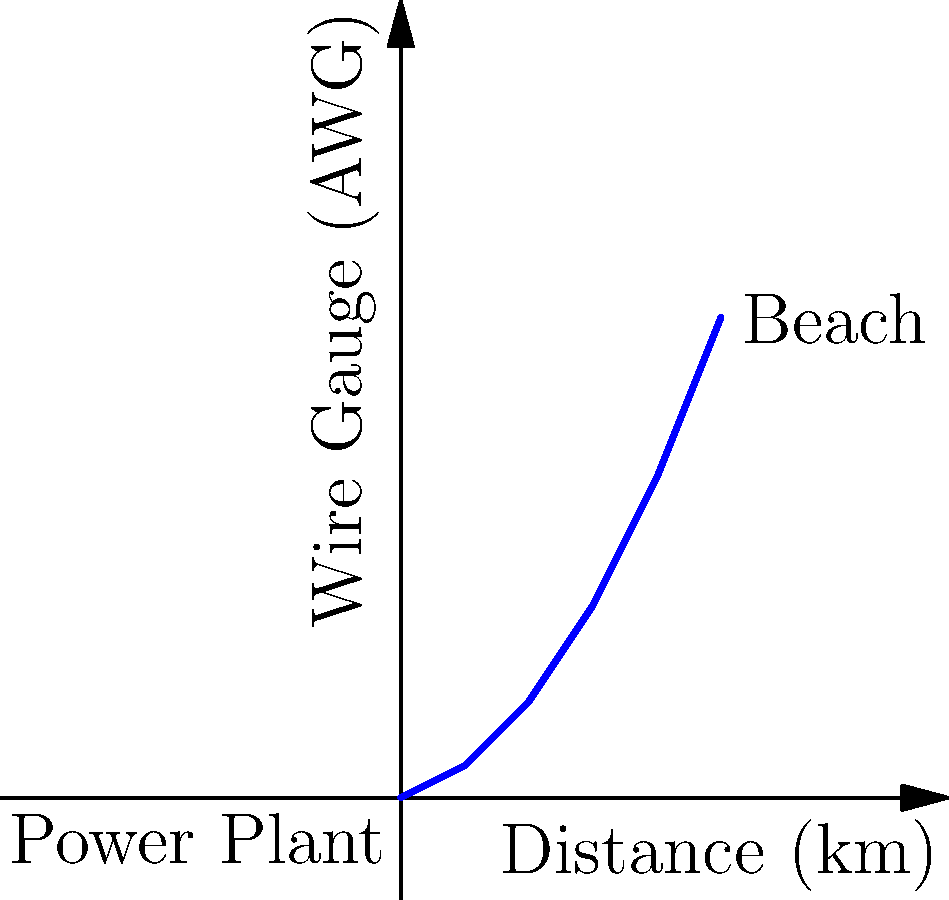A new power line is being installed to connect a coastal beach area in Newhaven to the main power grid. The distance from the power plant to the beach is 5 km. Given that the required current capacity is 100 A and the maximum allowable voltage drop is 2%, what is the minimum American Wire Gauge (AWG) needed for this power line? Assume the power line operates at 11 kV and the resistivity of copper is $1.68 \times 10^{-8}$ Ω⋅m. To determine the minimum wire gauge, we'll follow these steps:

1) First, calculate the maximum allowable resistance of the wire:
   Voltage drop = Current × Resistance
   $0.02 \times 11000 \text{ V} = 100 \text{ A} \times R$
   $R = \frac{220 \text{ V}}{100 \text{ A}} = 2.2 \text{ Ω}$

2) The resistance of a wire is given by:
   $R = \rho \frac{L}{A}$
   where $\rho$ is resistivity, $L$ is length, and $A$ is cross-sectional area.

3) Rearrange to solve for area:
   $A = \rho \frac{L}{R}$

4) Substitute known values:
   $A = (1.68 \times 10^{-8} \text{ Ω⋅m}) \frac{5000 \text{ m}}{2.2 \text{ Ω}} = 3.82 \times 10^{-5} \text{ m}^2$

5) Convert area to circular mils (CM):
   $1 \text{ CM} = 5.067 \times 10^{-10} \text{ m}^2$
   $A = 3.82 \times 10^{-5} \text{ m}^2 \div (5.067 \times 10^{-10} \text{ m}^2/\text{CM}) = 75,390 \text{ CM}$

6) Use AWG table to find the closest larger wire size:
   The closest larger size is AWG 1, which has a circular mil area of 83,690 CM.

Therefore, the minimum wire gauge needed is AWG 1.
Answer: AWG 1 